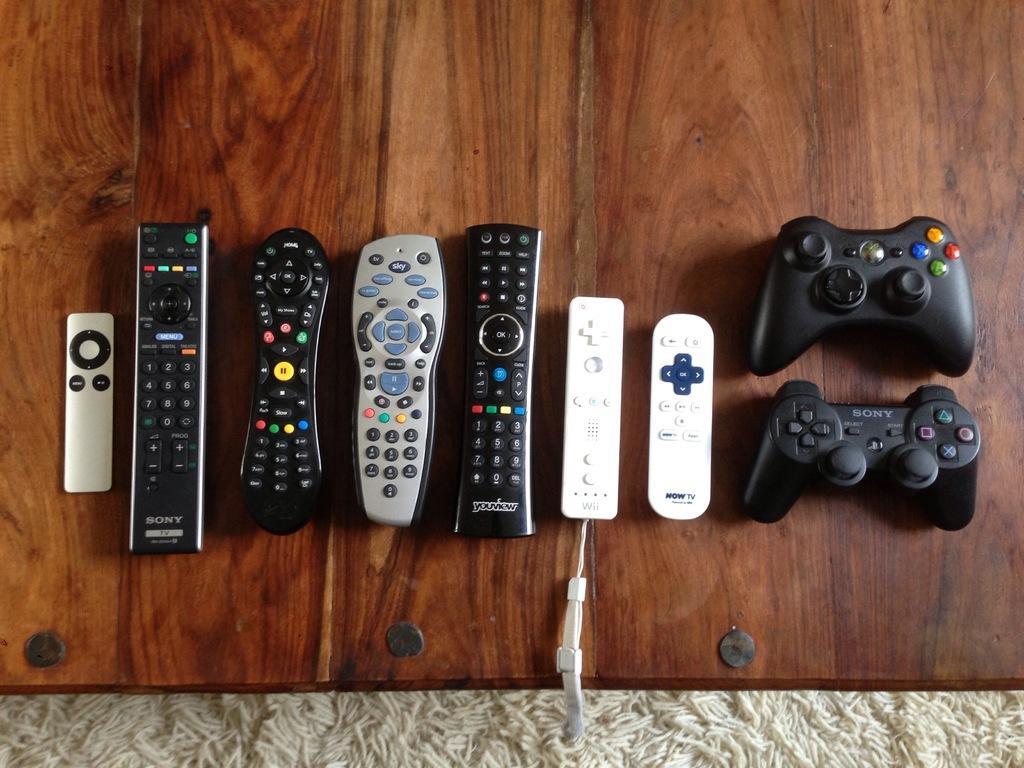Describe this image in one or two sentences. In this image few remotes and few joysticks are on the wooden plank. Bottom of image there is mat. Remotes are of different colours. Remotes and joysticks are having few buttons on them. 